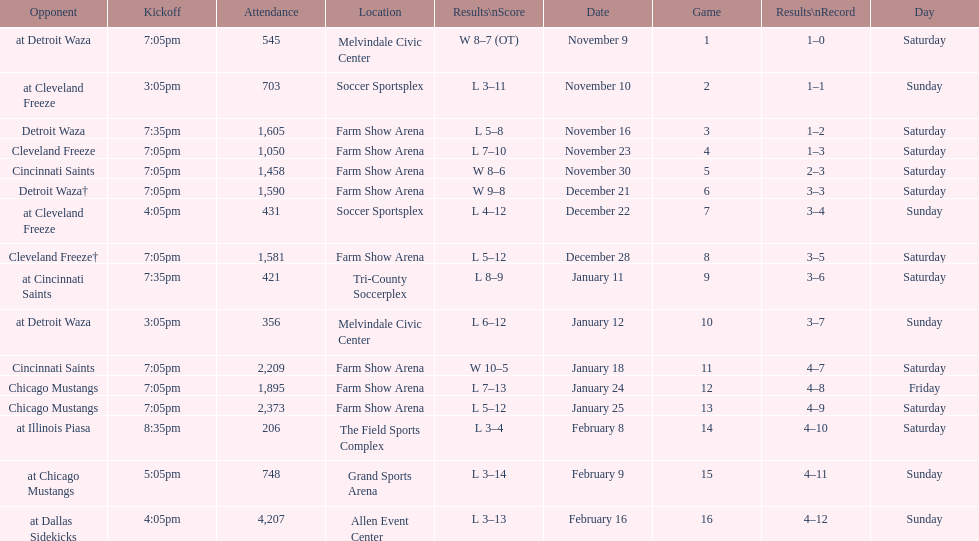What is the date of the game after december 22? December 28. 